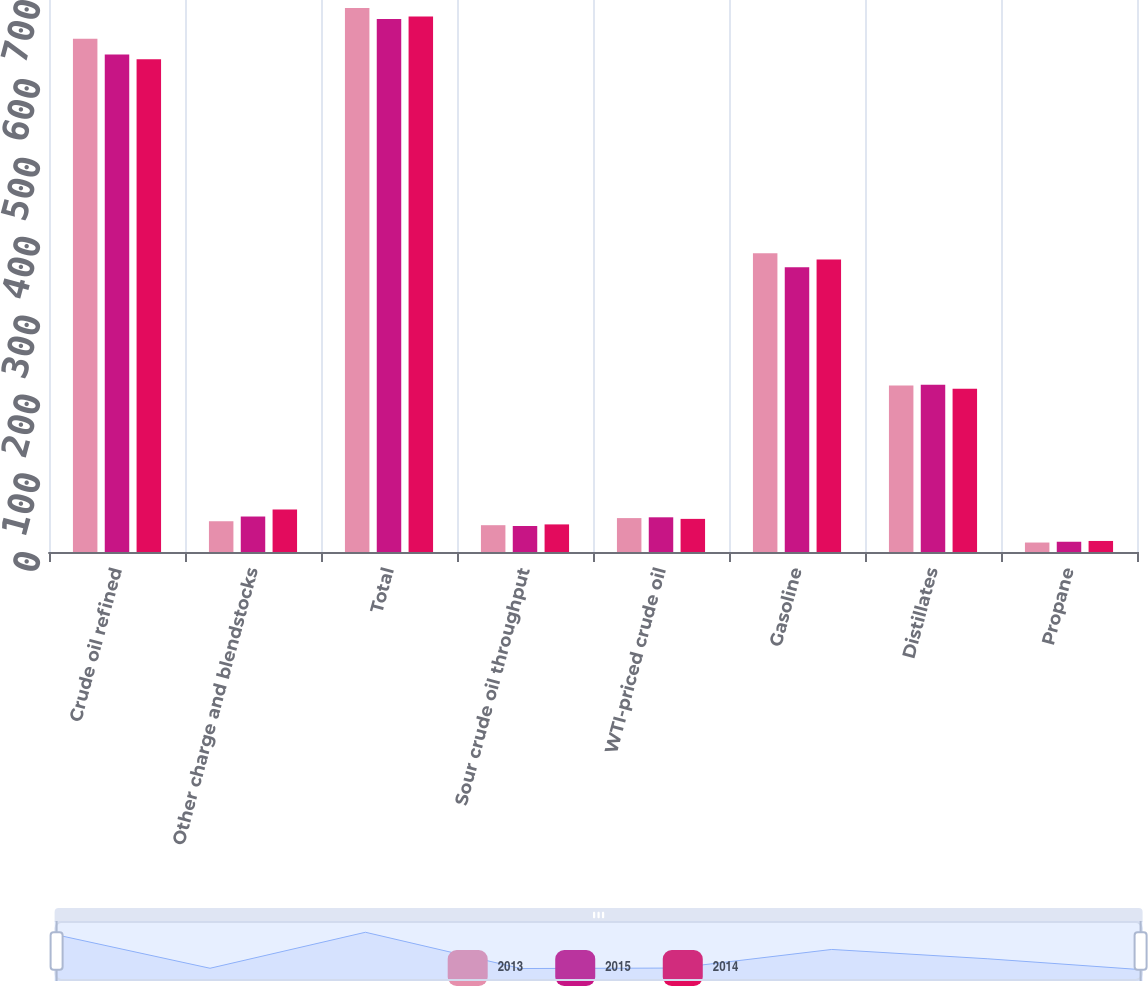Convert chart. <chart><loc_0><loc_0><loc_500><loc_500><stacked_bar_chart><ecel><fcel>Crude oil refined<fcel>Other charge and blendstocks<fcel>Total<fcel>Sour crude oil throughput<fcel>WTI-priced crude oil<fcel>Gasoline<fcel>Distillates<fcel>Propane<nl><fcel>2013<fcel>651<fcel>39<fcel>690<fcel>34<fcel>43<fcel>379<fcel>211<fcel>12<nl><fcel>2015<fcel>631<fcel>45<fcel>676<fcel>33<fcel>44<fcel>361<fcel>212<fcel>13<nl><fcel>2014<fcel>625<fcel>54<fcel>679<fcel>35<fcel>42<fcel>371<fcel>207<fcel>14<nl></chart> 